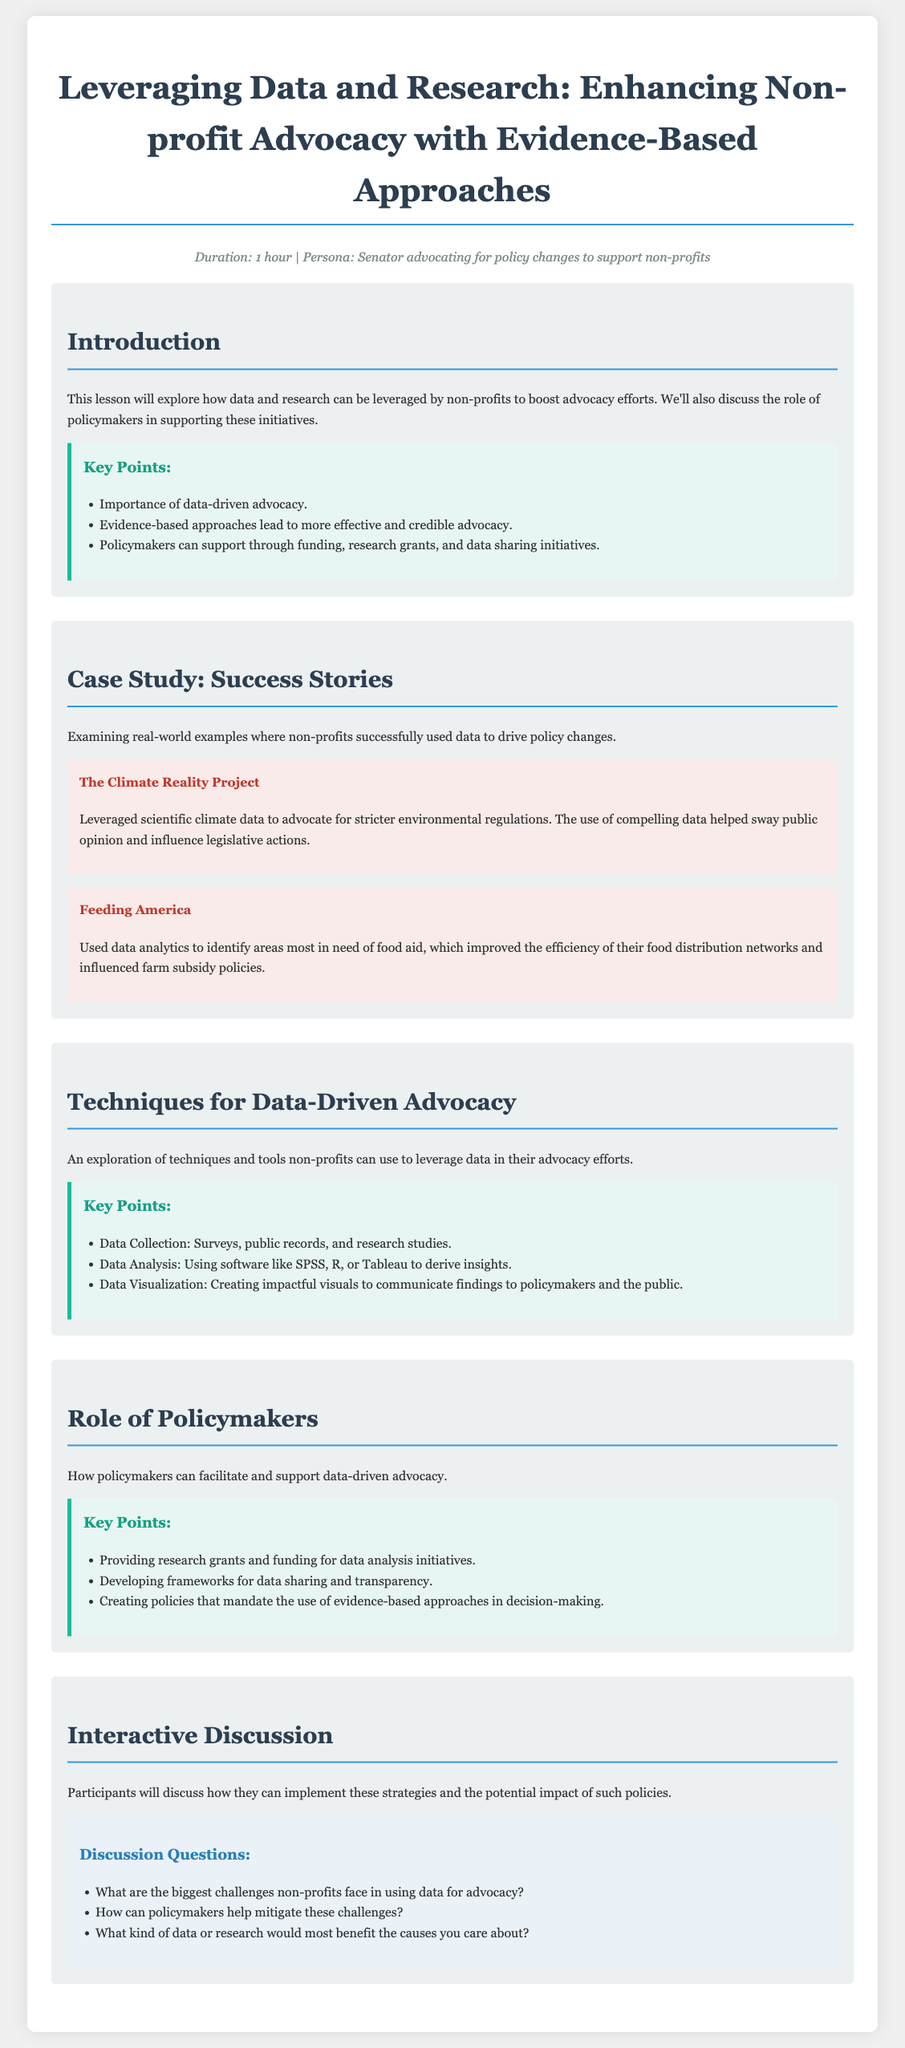What is the duration of the lesson? The duration of the lesson is mentioned in the meta-info section as "1 hour."
Answer: 1 hour What organization is mentioned in the success story about environmental regulations? The success story highlights "The Climate Reality Project" as an organization that used data effectively.
Answer: The Climate Reality Project What type of software is suggested for data analysis? The document lists several software options for data analysis, including "SPSS, R, or Tableau."
Answer: SPSS, R, or Tableau What are the three techniques for data-driven advocacy outlined in the document? The key points section lists "Data Collection, Data Analysis, Data Visualization" as techniques.
Answer: Data Collection, Data Analysis, Data Visualization What is one way policymakers can support non-profit data advocacy? The document suggests that policymakers can provide "research grants" to support data advocacy initiatives.
Answer: Research grants What is the focus of the interactive discussion section? The interactive discussion section is centered on how to implement advocacy strategies and their potential impacts.
Answer: Implementing advocacy strategies and potential impacts What is one challenge mentioned that non-profits face in using data for advocacy? The document asks about the biggest challenges non-profits face in using data but does not specify; however, it implies there are challenges in leveraging data.
Answer: Challenges in leveraging data What is the title of the lesson plan? The document has a clear title presented at the top: "Leveraging Data and Research: Enhancing Non-profit Advocacy with Evidence-Based Approaches."
Answer: Leveraging Data and Research: Enhancing Non-profit Advocacy with Evidence-Based Approaches How can policymakers ensure evidence-based approaches are used in decision-making? The document mentions that policymakers can create policies that mandate the use of evidence-based approaches.
Answer: Create policies that mandate the use of evidence-based approaches 